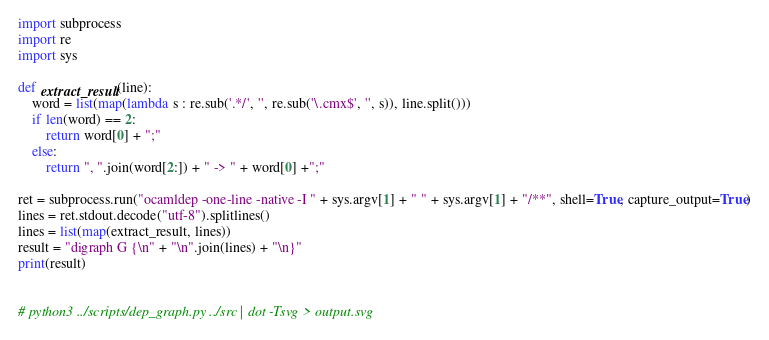Convert code to text. <code><loc_0><loc_0><loc_500><loc_500><_Python_>import subprocess
import re
import sys

def extract_result(line):
    word = list(map(lambda s : re.sub('.*/', '', re.sub('\.cmx$', '', s)), line.split()))
    if len(word) == 2:
        return word[0] + ";"
    else:
        return ", ".join(word[2:]) + " -> " + word[0] +";"

ret = subprocess.run("ocamldep -one-line -native -I " + sys.argv[1] + " " + sys.argv[1] + "/**", shell=True, capture_output=True)
lines = ret.stdout.decode("utf-8").splitlines()
lines = list(map(extract_result, lines))
result = "digraph G {\n" + "\n".join(lines) + "\n}"
print(result)


# python3 ../scripts/dep_graph.py ../src | dot -Tsvg > output.svg
</code> 